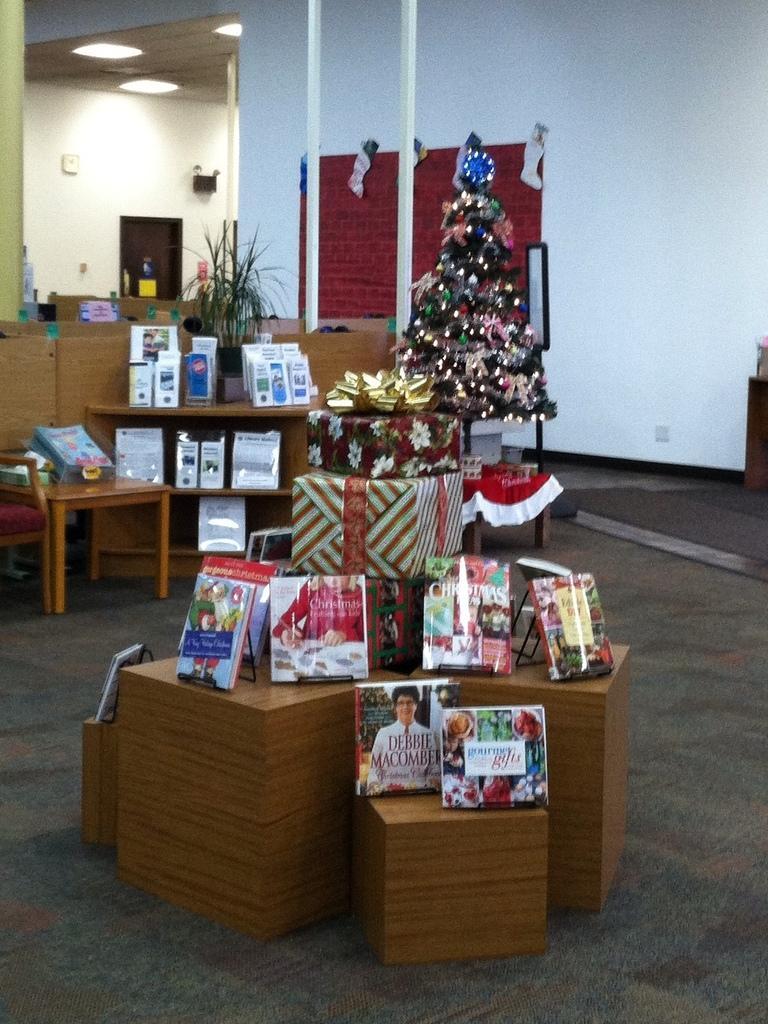In one or two sentences, can you explain what this image depicts? This picture shows a christmas tree and few packed gifts and a plant on the table 